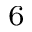<formula> <loc_0><loc_0><loc_500><loc_500>^ { 6 }</formula> 